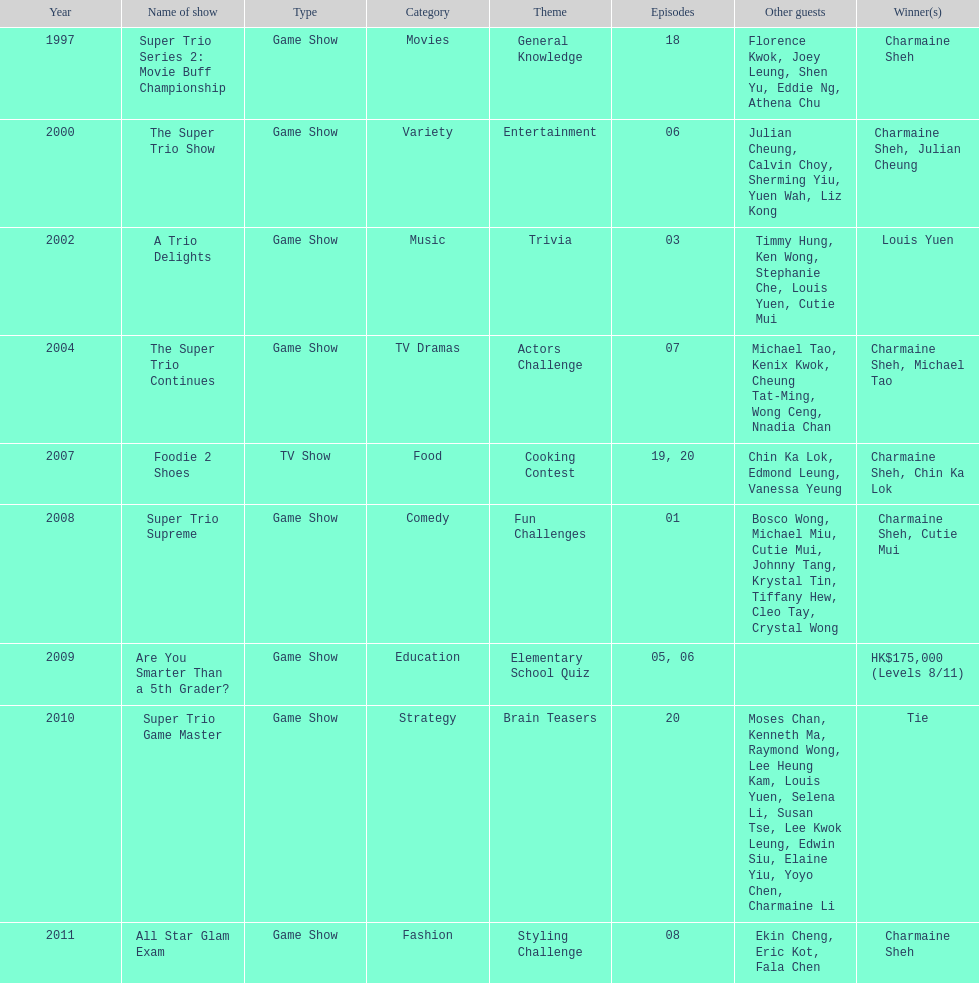What was the total number of trio series shows were charmaine sheh on? 6. 